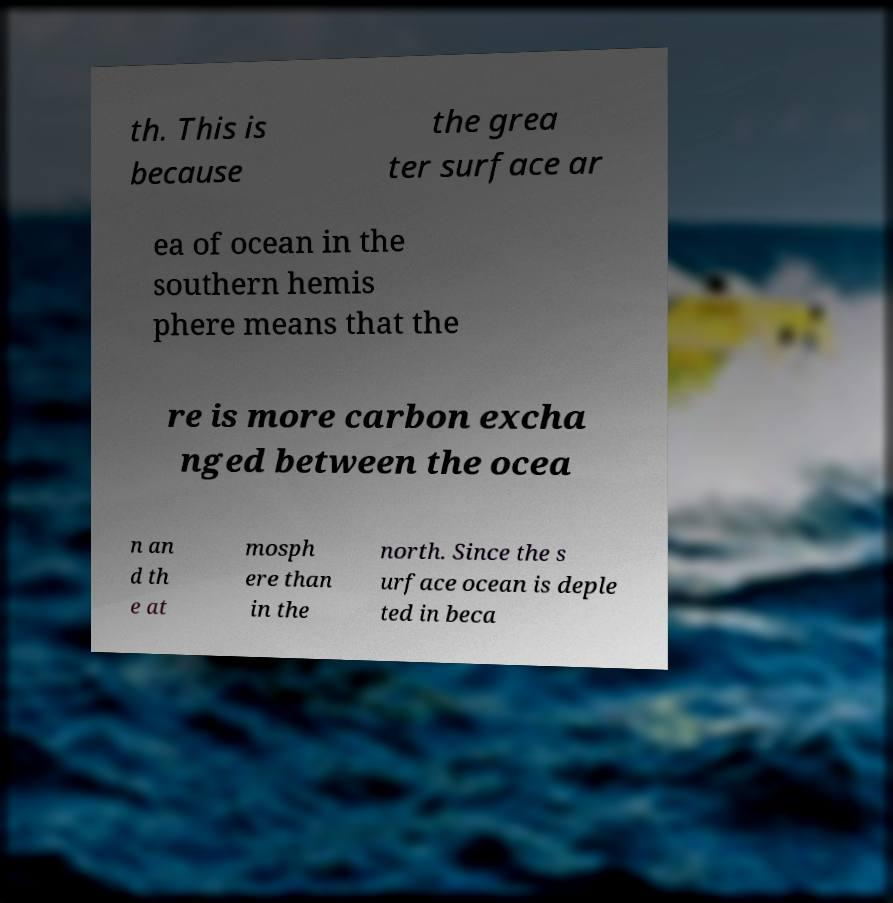Could you extract and type out the text from this image? th. This is because the grea ter surface ar ea of ocean in the southern hemis phere means that the re is more carbon excha nged between the ocea n an d th e at mosph ere than in the north. Since the s urface ocean is deple ted in beca 